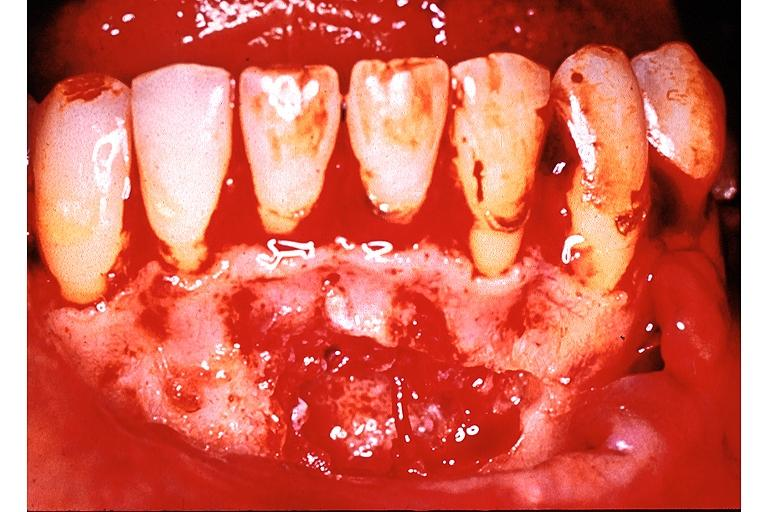does cervical carcinoma show traumatic bone cyst simple bone cyst?
Answer the question using a single word or phrase. No 